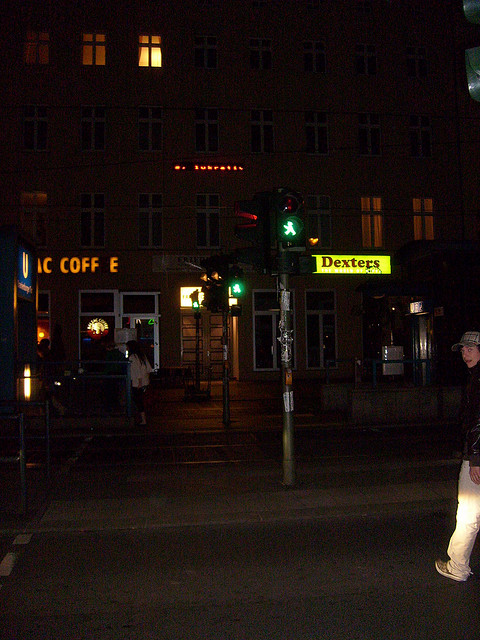Identify the text contained in this image. Dexters U Subratiz COFF E IC 